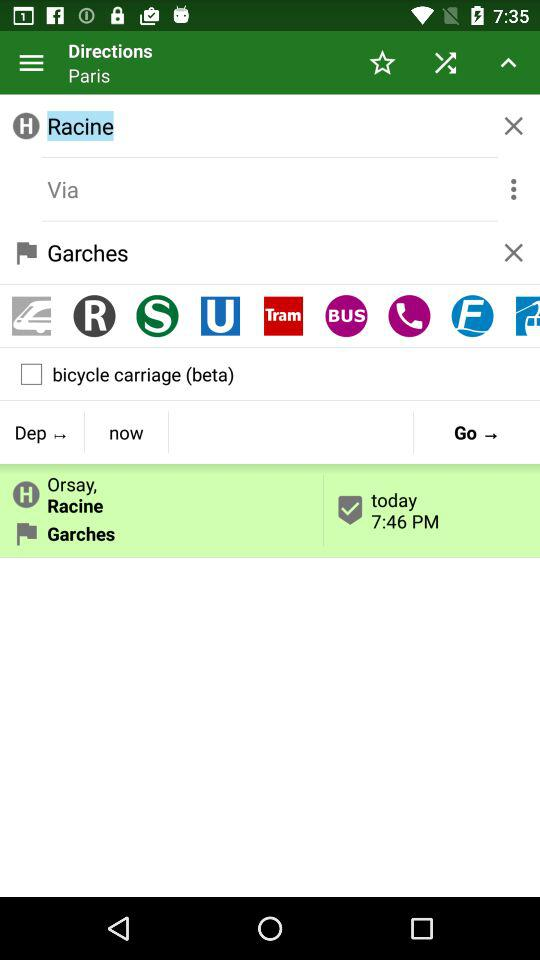What is the name shown on the screen?
When the provided information is insufficient, respond with <no answer>. <no answer> 